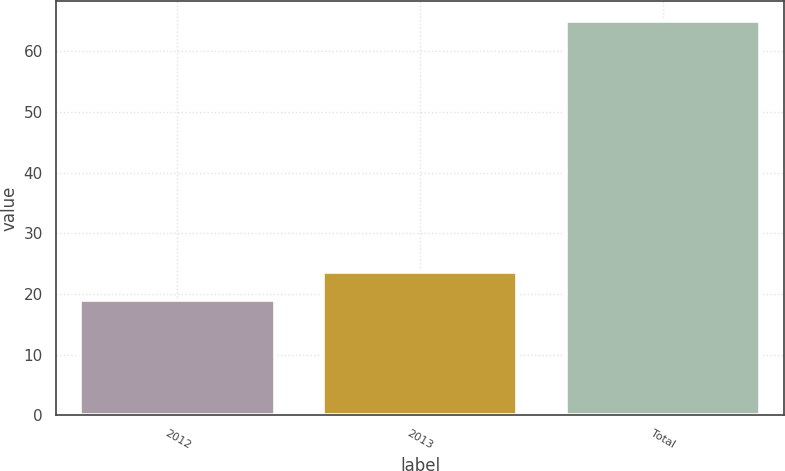Convert chart to OTSL. <chart><loc_0><loc_0><loc_500><loc_500><bar_chart><fcel>2012<fcel>2013<fcel>Total<nl><fcel>19<fcel>23.6<fcel>65<nl></chart> 